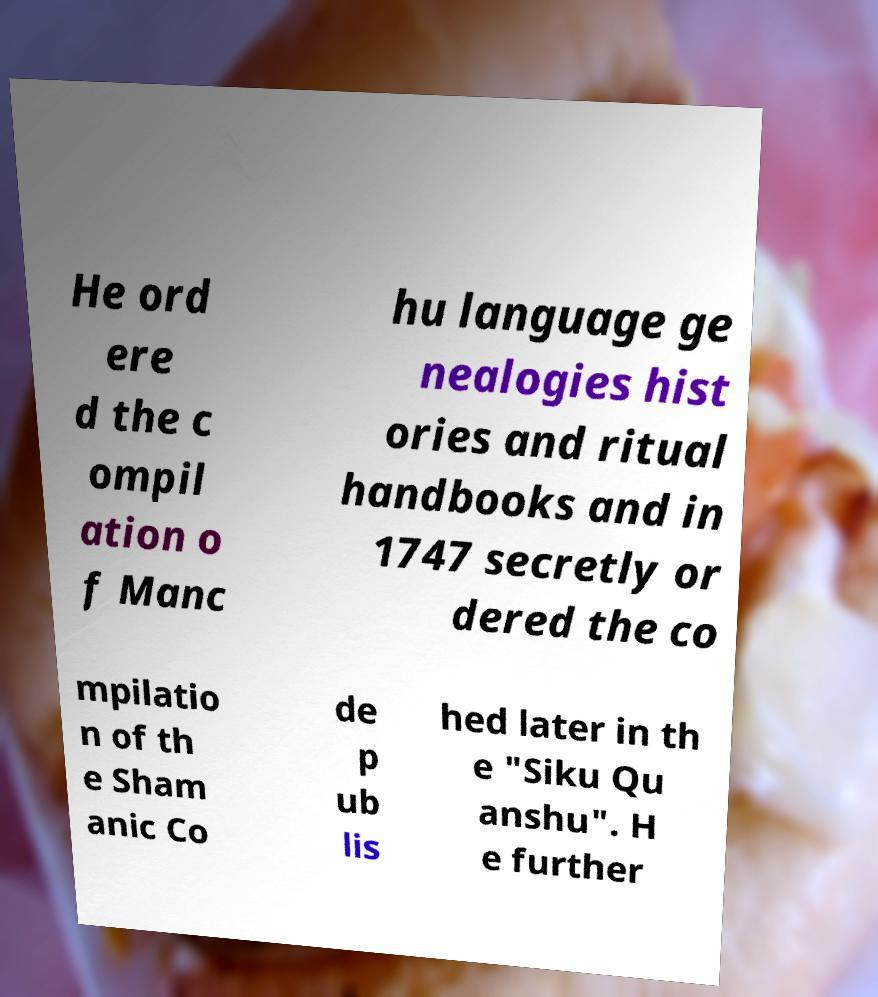Can you read and provide the text displayed in the image?This photo seems to have some interesting text. Can you extract and type it out for me? He ord ere d the c ompil ation o f Manc hu language ge nealogies hist ories and ritual handbooks and in 1747 secretly or dered the co mpilatio n of th e Sham anic Co de p ub lis hed later in th e "Siku Qu anshu". H e further 